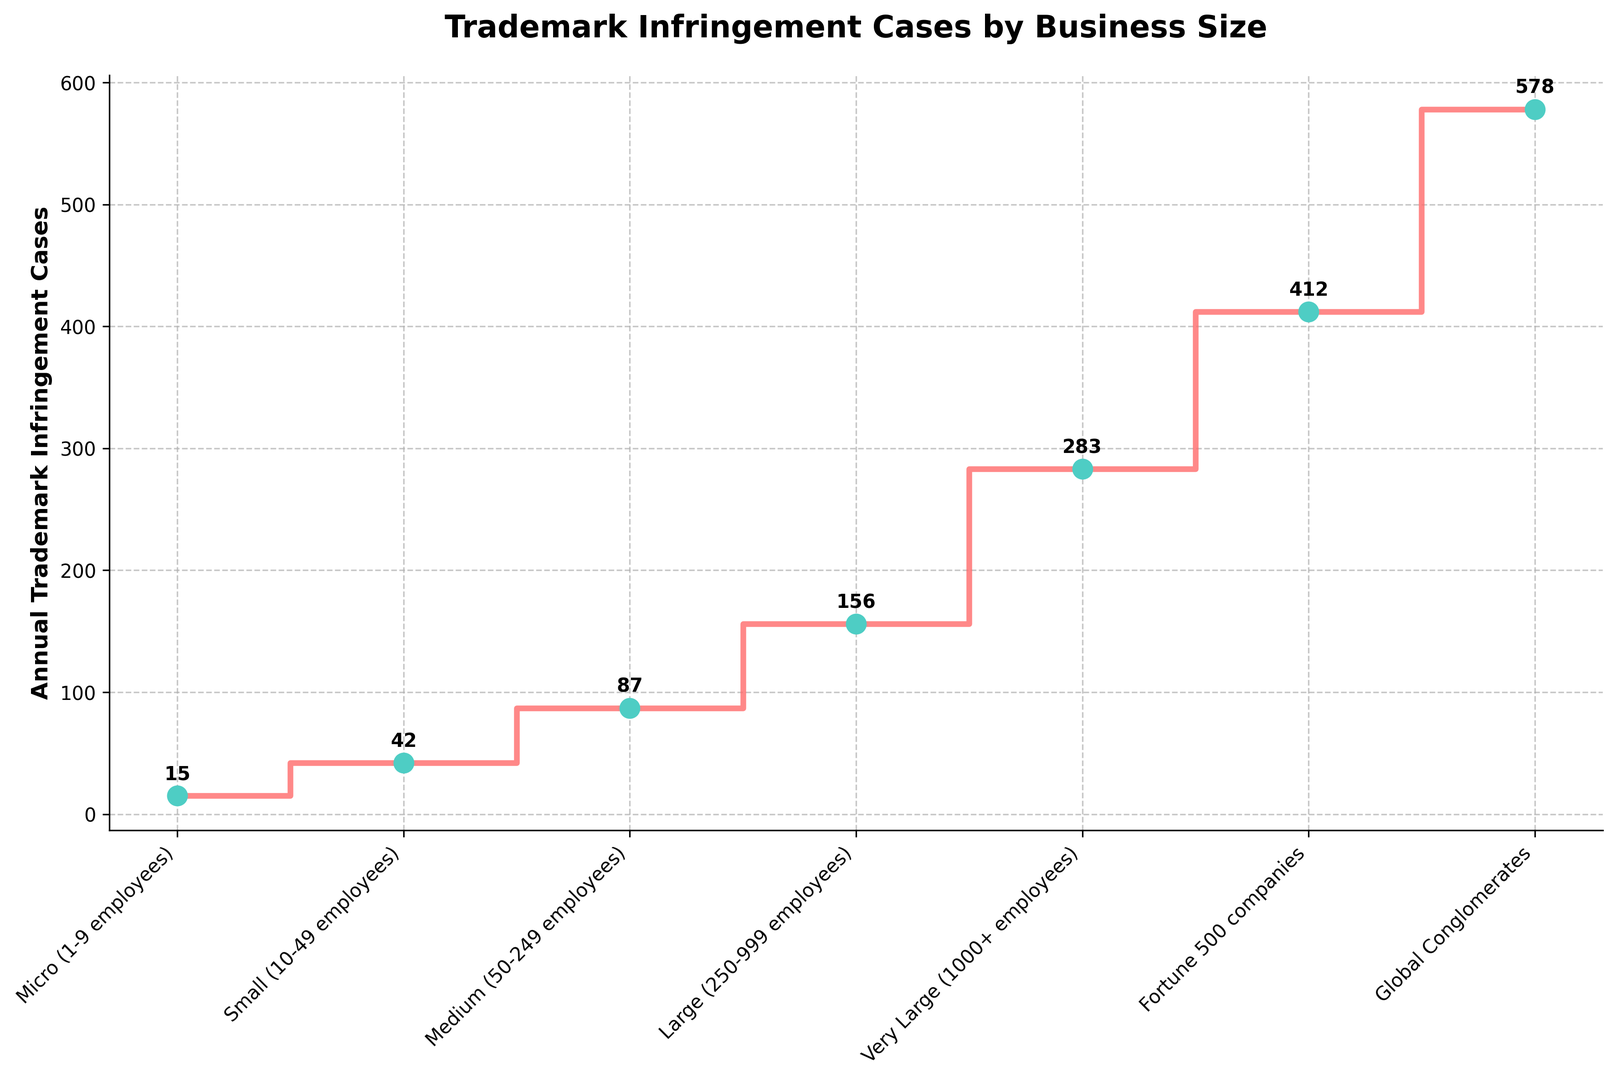Which business size category has the highest number of trademark infringement cases? The "Global Conglomerates" category has the highest point on the plot, indicating the largest number of cases.
Answer: Global Conglomerates What is the combined total of trademark infringement cases for "Micro" and "Small" businesses? The "Micro" category has 15 cases and the "Small" category has 42 cases. Adding them together gives 15 + 42 = 57 cases.
Answer: 57 How much does the number of cases increase from "Medium" to "Large" businesses? The "Medium" category has 87 cases, and the "Large" category has 156 cases. The increase is 156 - 87 = 69 cases.
Answer: 69 Which two business size categories have case numbers closest to each other? By comparing the numbers, "Large" (156 cases) and "Very Large" (283 cases) have a difference of 283 - 156 = 127. On closer inspection, the other categories have larger differences.
Answer: Large and Very Large What is the average number of trademark infringement cases across all business size categories? Add all the cases together and divide by the number of categories: (15 + 42 + 87 + 156 + 283 + 412 + 578) / 7. Doing the math gives (1573 / 7) ≈ 224.7 cases.
Answer: 224.7 By how many cases does the "Fortune 500 companies" category exceed the "Very Large" businesses? The "Fortune 500 companies" has 412 cases and "Very Large" has 283 cases. The difference is 412 - 283 = 129 cases.
Answer: 129 Which category shows a steep increase in cases after "Medium" businesses? After "Medium" (87 cases), the "Large" businesses jump to 156 cases, showing a steep increase.
Answer: Large Do any two consecutive categories have more than a 200-case difference? By comparing the differences: 
- Small to Medium: 87 - 42 = 45
- Medium to Large: 156 - 87 = 69
- Large to Very Large: 283 - 156 = 127
- Very Large to Fortune 500: 412 - 283 = 129
- Fortune 500 to Global Conglomerates: 578 - 412 = 166
None exceed 200.
Answer: No 